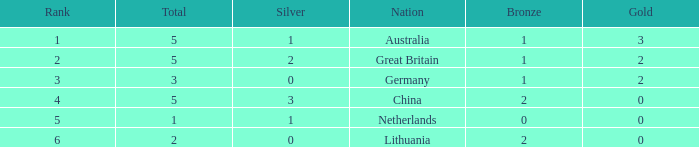What is the mean gold when the ranking is below 3 and the number of bronze is less than 1? None. 